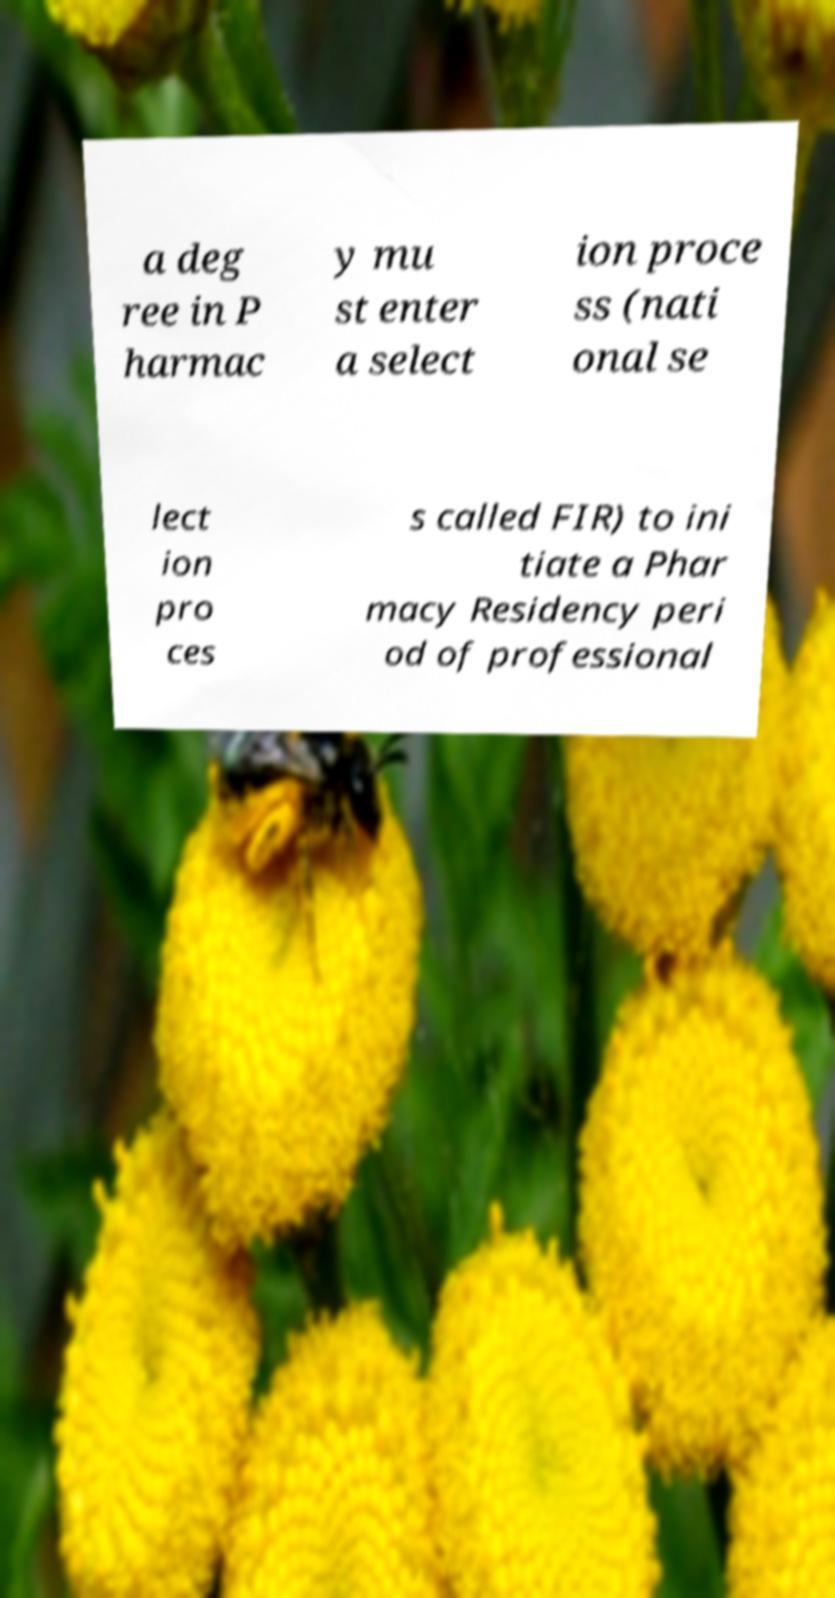What messages or text are displayed in this image? I need them in a readable, typed format. a deg ree in P harmac y mu st enter a select ion proce ss (nati onal se lect ion pro ces s called FIR) to ini tiate a Phar macy Residency peri od of professional 